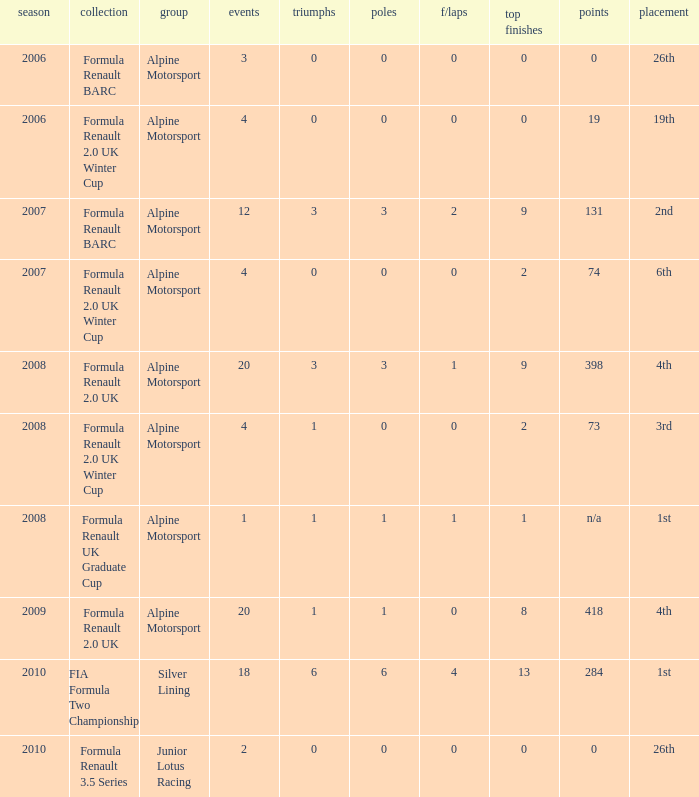What was the earliest season where podium was 9? 2007.0. 